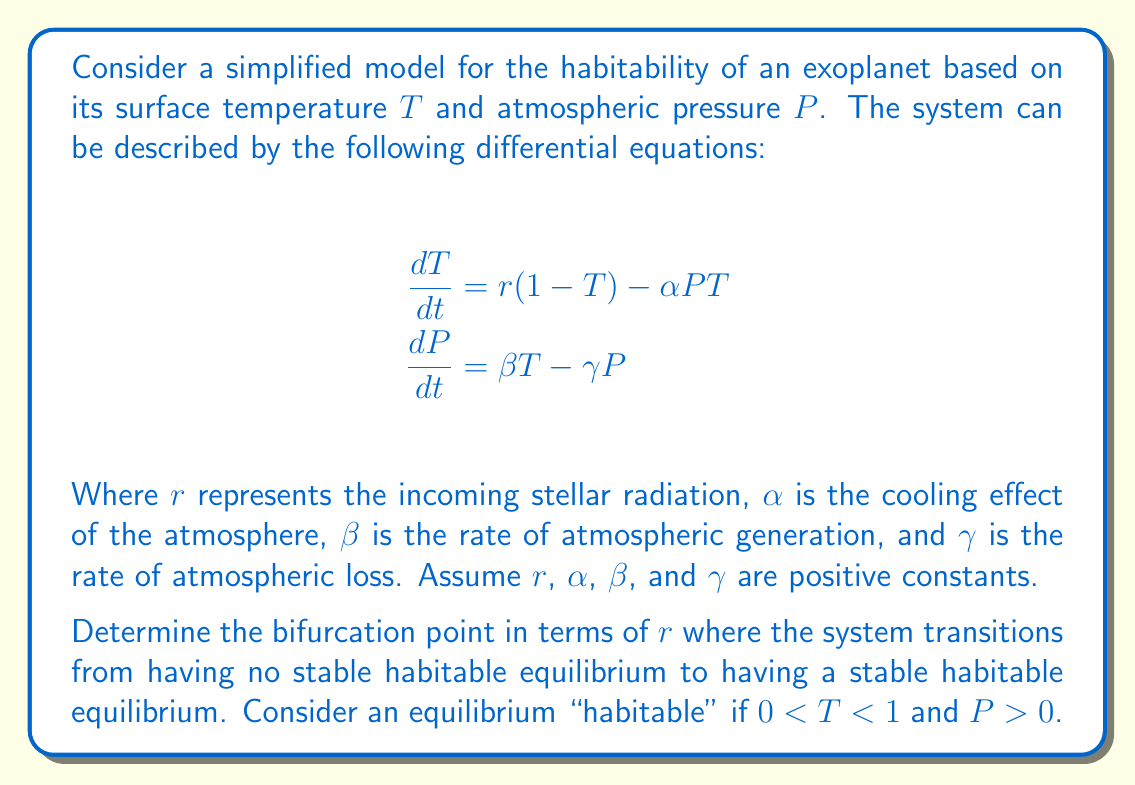What is the answer to this math problem? To solve this problem, we'll follow these steps:

1) Find the equilibrium points of the system.
2) Analyze the stability of these equilibrium points.
3) Determine the bifurcation point.

Step 1: Finding equilibrium points

At equilibrium, $\frac{dT}{dt} = \frac{dP}{dt} = 0$. So:

$$r(1-T) - \alpha P T = 0 \quad (1)$$
$$\beta T - \gamma P = 0 \quad (2)$$

From (2), we can express $P$ in terms of $T$:

$$P = \frac{\beta T}{\gamma} \quad (3)$$

Substituting (3) into (1):

$$r(1-T) - \alpha \frac{\beta T^2}{\gamma} = 0$$

$$r - rT - \frac{\alpha \beta}{\gamma} T^2 = 0$$

This is a quadratic equation in $T$. Let $a = \frac{\alpha \beta}{\gamma}$, then:

$$aT^2 + rT - r = 0 \quad (4)$$

Step 2: Analyzing stability

The solutions to equation (4) give us the equilibrium points. For habitability, we're interested in solutions where $0 < T < 1$.

The discriminant of (4) is $\Delta = r^2 + 4ar$. For real solutions, we need $\Delta \geq 0$, which is always true for positive $r$ and $a$.

The solutions are:

$$T = \frac{-r \pm \sqrt{r^2 + 4ar}}{2a}$$

For a habitable equilibrium, we need the positive root to be less than 1:

$$\frac{-r + \sqrt{r^2 + 4ar}}{2a} < 1$$

Step 3: Determining the bifurcation point

The bifurcation occurs when the positive root equals 1. So:

$$\frac{-r + \sqrt{r^2 + 4ar}}{2a} = 1$$

Solving this:

$$-r + \sqrt{r^2 + 4ar} = 2a$$
$$r^2 + 4ar = (2a + r)^2$$
$$r^2 + 4ar = 4a^2 + 4ar + r^2$$
$$0 = 4a^2$$
$$a = 0$$

However, $a = 0$ is not possible given our assumptions. This means that as long as $a > 0$, there will always be one equilibrium point with $T > 1$ (uninhabitable) and one with $0 < T < 1$ (potentially habitable).

The actual bifurcation occurs when the potentially habitable equilibrium point becomes stable. This happens when $r = a = \frac{\alpha \beta}{\gamma}$.

When $r < \frac{\alpha \beta}{\gamma}$, the habitable equilibrium is unstable. When $r > \frac{\alpha \beta}{\gamma}$, it becomes stable.
Answer: $r = \frac{\alpha \beta}{\gamma}$ 